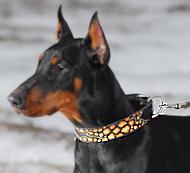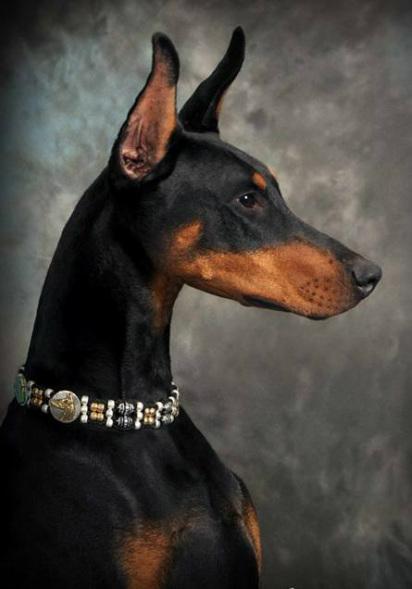The first image is the image on the left, the second image is the image on the right. Assess this claim about the two images: "Each image shows at least one doberman wearing a collar, and one image shows a camera-gazing close-mouthed dog in a chain collar, while the other image includes a rightward-gazing dog with its pink tongue hanging out.". Correct or not? Answer yes or no. No. The first image is the image on the left, the second image is the image on the right. Considering the images on both sides, is "At least one doberman has its tongue out." valid? Answer yes or no. No. 